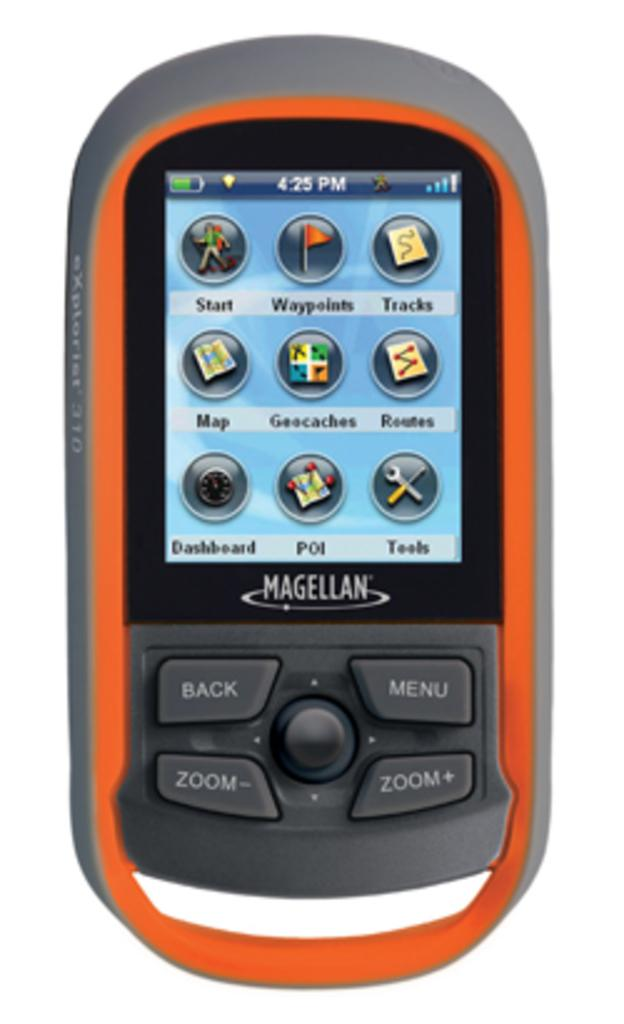Provide a one-sentence caption for the provided image. An orange Magellan phone is at its menu. 